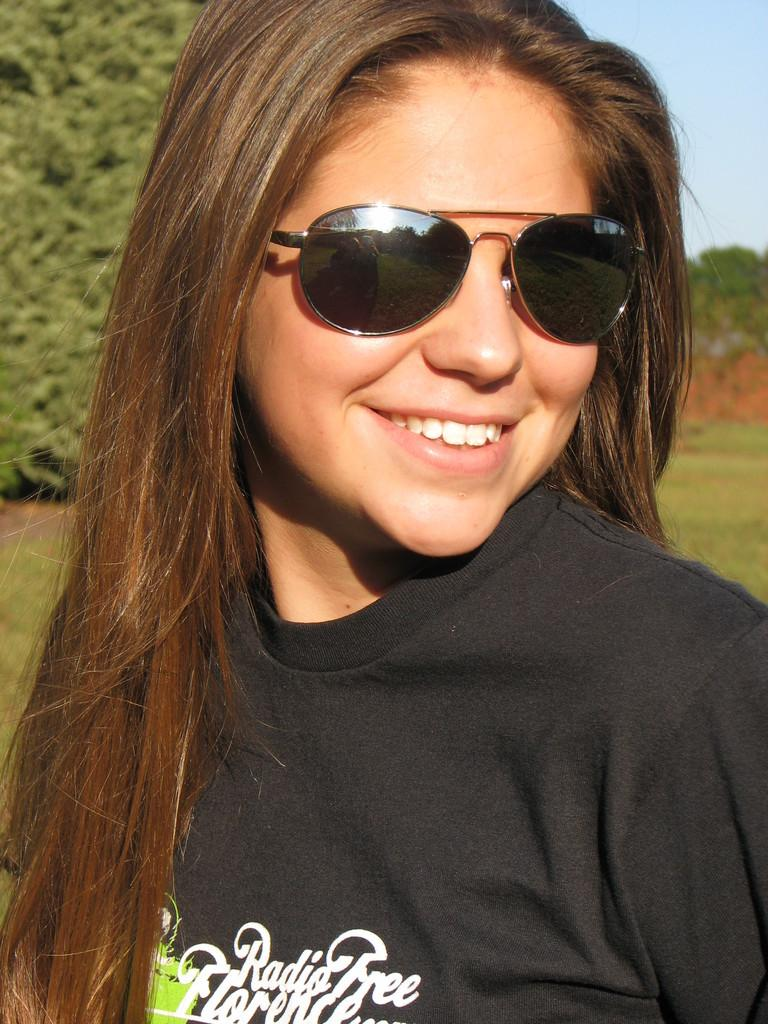Who is present in the image? There is a person in the image. What is the person wearing? The person is wearing a black shirt. What can be seen in the background of the image? There are trees and the sky visible in the background of the image. What is the color of the trees in the image? The trees are green. What is the color of the sky in the image? The sky is blue. What type of grain is being stored in the jail in the image? There is no grain or jail present in the image; it features a person wearing a black shirt with green trees and a blue sky in the background. 